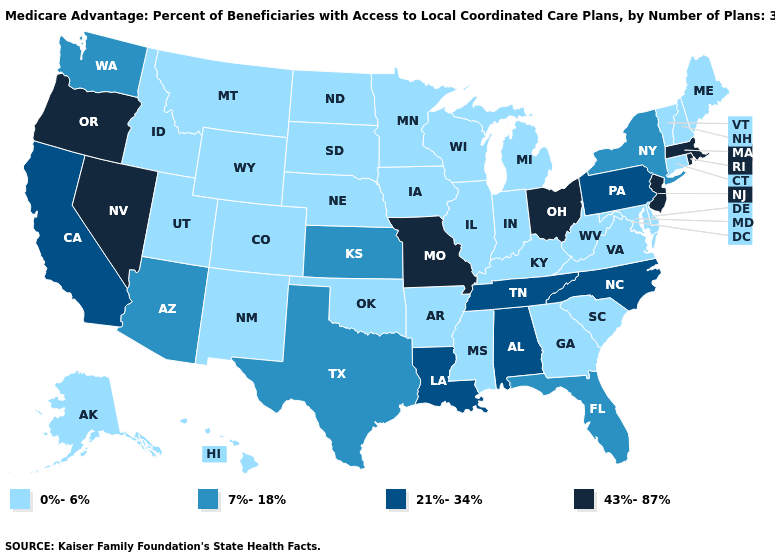Name the states that have a value in the range 21%-34%?
Give a very brief answer. Alabama, California, Louisiana, North Carolina, Pennsylvania, Tennessee. Does West Virginia have the highest value in the USA?
Give a very brief answer. No. Among the states that border Minnesota , which have the highest value?
Keep it brief. Iowa, North Dakota, South Dakota, Wisconsin. Does Missouri have the highest value in the MidWest?
Concise answer only. Yes. What is the lowest value in the USA?
Answer briefly. 0%-6%. Does the first symbol in the legend represent the smallest category?
Be succinct. Yes. Does New Mexico have the highest value in the West?
Answer briefly. No. How many symbols are there in the legend?
Answer briefly. 4. What is the highest value in states that border Arizona?
Be succinct. 43%-87%. Name the states that have a value in the range 21%-34%?
Short answer required. Alabama, California, Louisiana, North Carolina, Pennsylvania, Tennessee. Which states have the lowest value in the South?
Quick response, please. Arkansas, Delaware, Georgia, Kentucky, Maryland, Mississippi, Oklahoma, South Carolina, Virginia, West Virginia. What is the value of West Virginia?
Keep it brief. 0%-6%. What is the value of South Carolina?
Quick response, please. 0%-6%. Name the states that have a value in the range 43%-87%?
Concise answer only. Massachusetts, Missouri, New Jersey, Nevada, Ohio, Oregon, Rhode Island. 